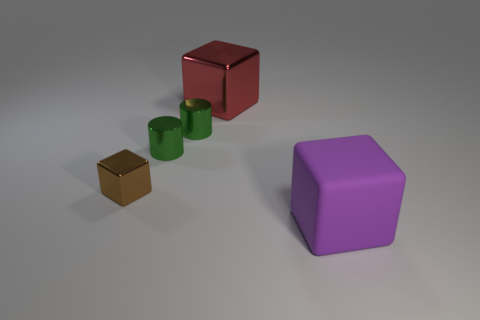There is a large object behind the large cube in front of the large object that is behind the purple matte block; what color is it?
Ensure brevity in your answer.  Red. Are there an equal number of big metallic cubes that are to the right of the large purple rubber object and brown blocks that are right of the small brown metal block?
Keep it short and to the point. Yes. The other metal thing that is the same size as the purple thing is what shape?
Ensure brevity in your answer.  Cube. Are there any cubes that have the same color as the rubber thing?
Your response must be concise. No. There is a large thing that is behind the brown object; what is its shape?
Make the answer very short. Cube. What is the color of the tiny shiny cube?
Your answer should be very brief. Brown. What color is the small block that is the same material as the big red cube?
Provide a short and direct response. Brown. What number of small cylinders have the same material as the purple cube?
Provide a short and direct response. 0. There is a tiny brown thing; how many purple rubber cubes are to the left of it?
Keep it short and to the point. 0. Do the large cube that is in front of the big red metal cube and the large block that is behind the purple matte thing have the same material?
Ensure brevity in your answer.  No. 